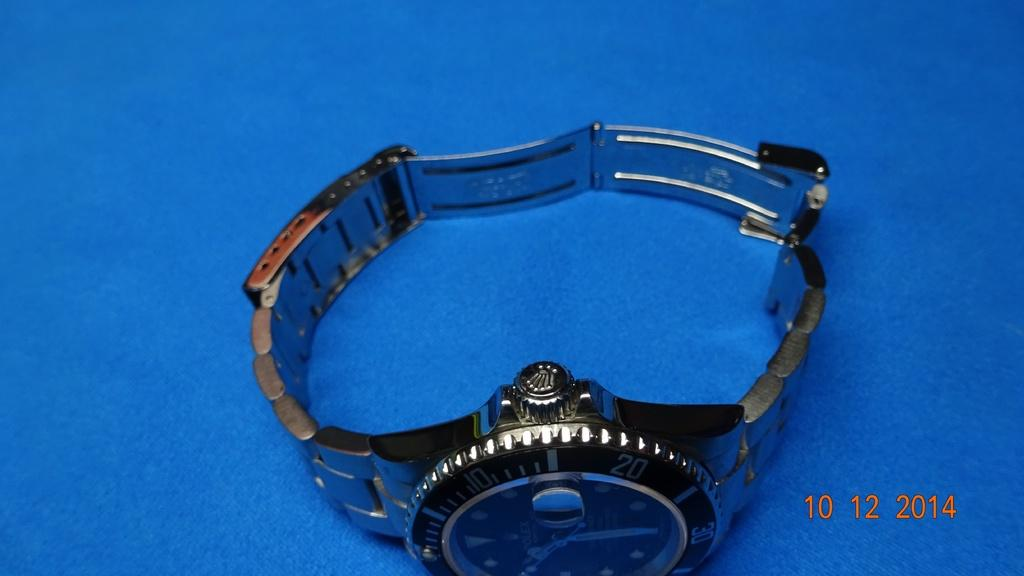<image>
Provide a brief description of the given image. A photo of a wristwatch with a metal band, bears the time stamp 10 12 2014. 